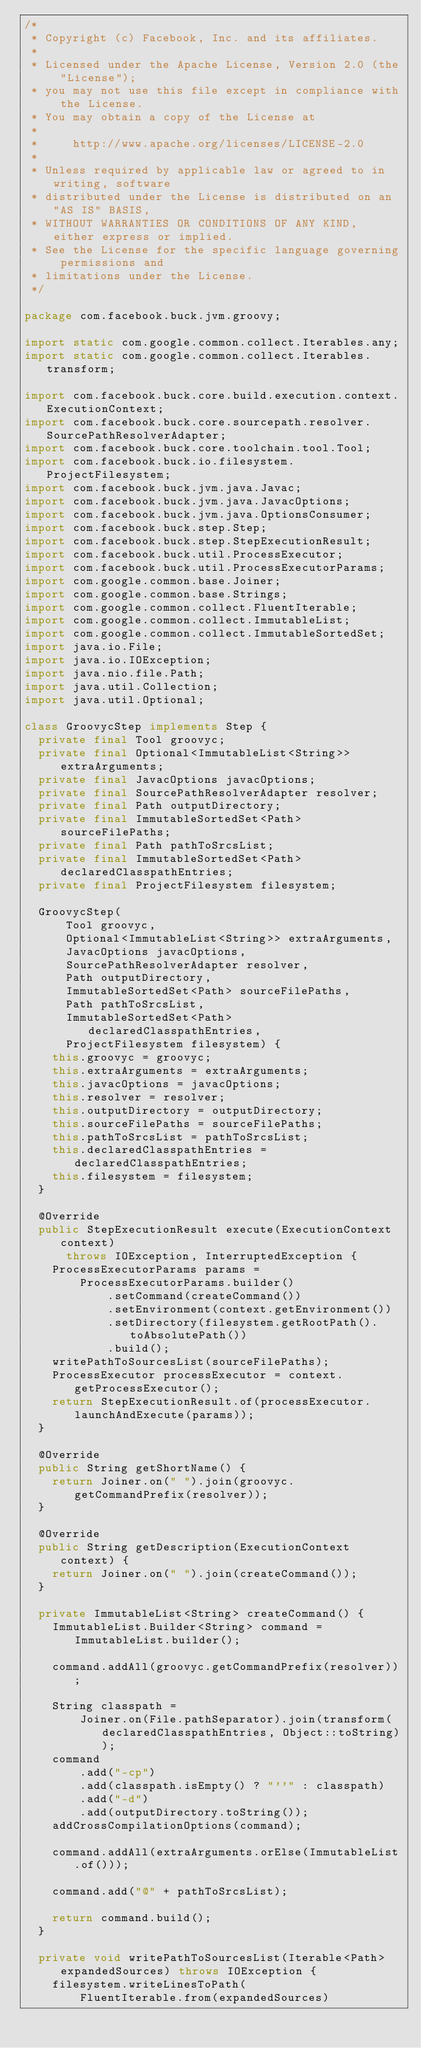Convert code to text. <code><loc_0><loc_0><loc_500><loc_500><_Java_>/*
 * Copyright (c) Facebook, Inc. and its affiliates.
 *
 * Licensed under the Apache License, Version 2.0 (the "License");
 * you may not use this file except in compliance with the License.
 * You may obtain a copy of the License at
 *
 *     http://www.apache.org/licenses/LICENSE-2.0
 *
 * Unless required by applicable law or agreed to in writing, software
 * distributed under the License is distributed on an "AS IS" BASIS,
 * WITHOUT WARRANTIES OR CONDITIONS OF ANY KIND, either express or implied.
 * See the License for the specific language governing permissions and
 * limitations under the License.
 */

package com.facebook.buck.jvm.groovy;

import static com.google.common.collect.Iterables.any;
import static com.google.common.collect.Iterables.transform;

import com.facebook.buck.core.build.execution.context.ExecutionContext;
import com.facebook.buck.core.sourcepath.resolver.SourcePathResolverAdapter;
import com.facebook.buck.core.toolchain.tool.Tool;
import com.facebook.buck.io.filesystem.ProjectFilesystem;
import com.facebook.buck.jvm.java.Javac;
import com.facebook.buck.jvm.java.JavacOptions;
import com.facebook.buck.jvm.java.OptionsConsumer;
import com.facebook.buck.step.Step;
import com.facebook.buck.step.StepExecutionResult;
import com.facebook.buck.util.ProcessExecutor;
import com.facebook.buck.util.ProcessExecutorParams;
import com.google.common.base.Joiner;
import com.google.common.base.Strings;
import com.google.common.collect.FluentIterable;
import com.google.common.collect.ImmutableList;
import com.google.common.collect.ImmutableSortedSet;
import java.io.File;
import java.io.IOException;
import java.nio.file.Path;
import java.util.Collection;
import java.util.Optional;

class GroovycStep implements Step {
  private final Tool groovyc;
  private final Optional<ImmutableList<String>> extraArguments;
  private final JavacOptions javacOptions;
  private final SourcePathResolverAdapter resolver;
  private final Path outputDirectory;
  private final ImmutableSortedSet<Path> sourceFilePaths;
  private final Path pathToSrcsList;
  private final ImmutableSortedSet<Path> declaredClasspathEntries;
  private final ProjectFilesystem filesystem;

  GroovycStep(
      Tool groovyc,
      Optional<ImmutableList<String>> extraArguments,
      JavacOptions javacOptions,
      SourcePathResolverAdapter resolver,
      Path outputDirectory,
      ImmutableSortedSet<Path> sourceFilePaths,
      Path pathToSrcsList,
      ImmutableSortedSet<Path> declaredClasspathEntries,
      ProjectFilesystem filesystem) {
    this.groovyc = groovyc;
    this.extraArguments = extraArguments;
    this.javacOptions = javacOptions;
    this.resolver = resolver;
    this.outputDirectory = outputDirectory;
    this.sourceFilePaths = sourceFilePaths;
    this.pathToSrcsList = pathToSrcsList;
    this.declaredClasspathEntries = declaredClasspathEntries;
    this.filesystem = filesystem;
  }

  @Override
  public StepExecutionResult execute(ExecutionContext context)
      throws IOException, InterruptedException {
    ProcessExecutorParams params =
        ProcessExecutorParams.builder()
            .setCommand(createCommand())
            .setEnvironment(context.getEnvironment())
            .setDirectory(filesystem.getRootPath().toAbsolutePath())
            .build();
    writePathToSourcesList(sourceFilePaths);
    ProcessExecutor processExecutor = context.getProcessExecutor();
    return StepExecutionResult.of(processExecutor.launchAndExecute(params));
  }

  @Override
  public String getShortName() {
    return Joiner.on(" ").join(groovyc.getCommandPrefix(resolver));
  }

  @Override
  public String getDescription(ExecutionContext context) {
    return Joiner.on(" ").join(createCommand());
  }

  private ImmutableList<String> createCommand() {
    ImmutableList.Builder<String> command = ImmutableList.builder();

    command.addAll(groovyc.getCommandPrefix(resolver));

    String classpath =
        Joiner.on(File.pathSeparator).join(transform(declaredClasspathEntries, Object::toString));
    command
        .add("-cp")
        .add(classpath.isEmpty() ? "''" : classpath)
        .add("-d")
        .add(outputDirectory.toString());
    addCrossCompilationOptions(command);

    command.addAll(extraArguments.orElse(ImmutableList.of()));

    command.add("@" + pathToSrcsList);

    return command.build();
  }

  private void writePathToSourcesList(Iterable<Path> expandedSources) throws IOException {
    filesystem.writeLinesToPath(
        FluentIterable.from(expandedSources)</code> 